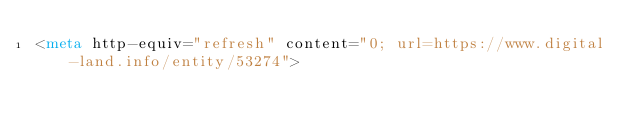Convert code to text. <code><loc_0><loc_0><loc_500><loc_500><_HTML_><meta http-equiv="refresh" content="0; url=https://www.digital-land.info/entity/53274"></code> 